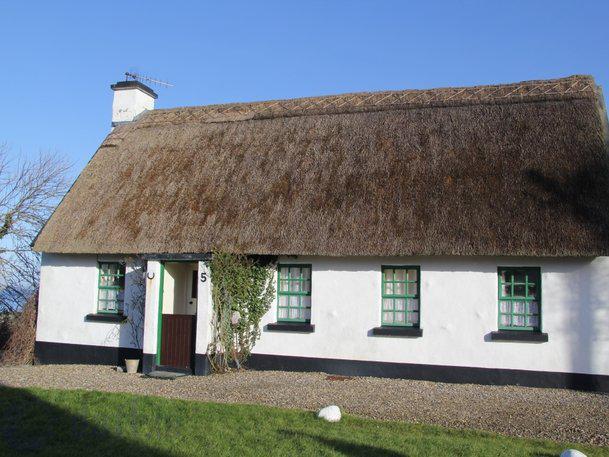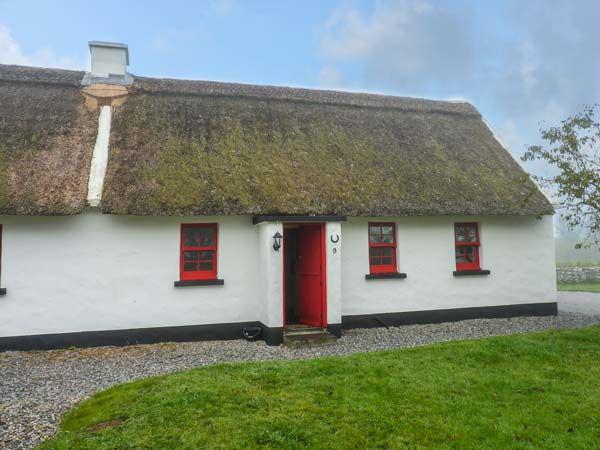The first image is the image on the left, the second image is the image on the right. Considering the images on both sides, is "There are two windows on the left side of the door in at least one of the pictures." valid? Answer yes or no. No. The first image is the image on the left, the second image is the image on the right. Considering the images on both sides, is "One of the houses has neither a red door nor red window trim." valid? Answer yes or no. Yes. 